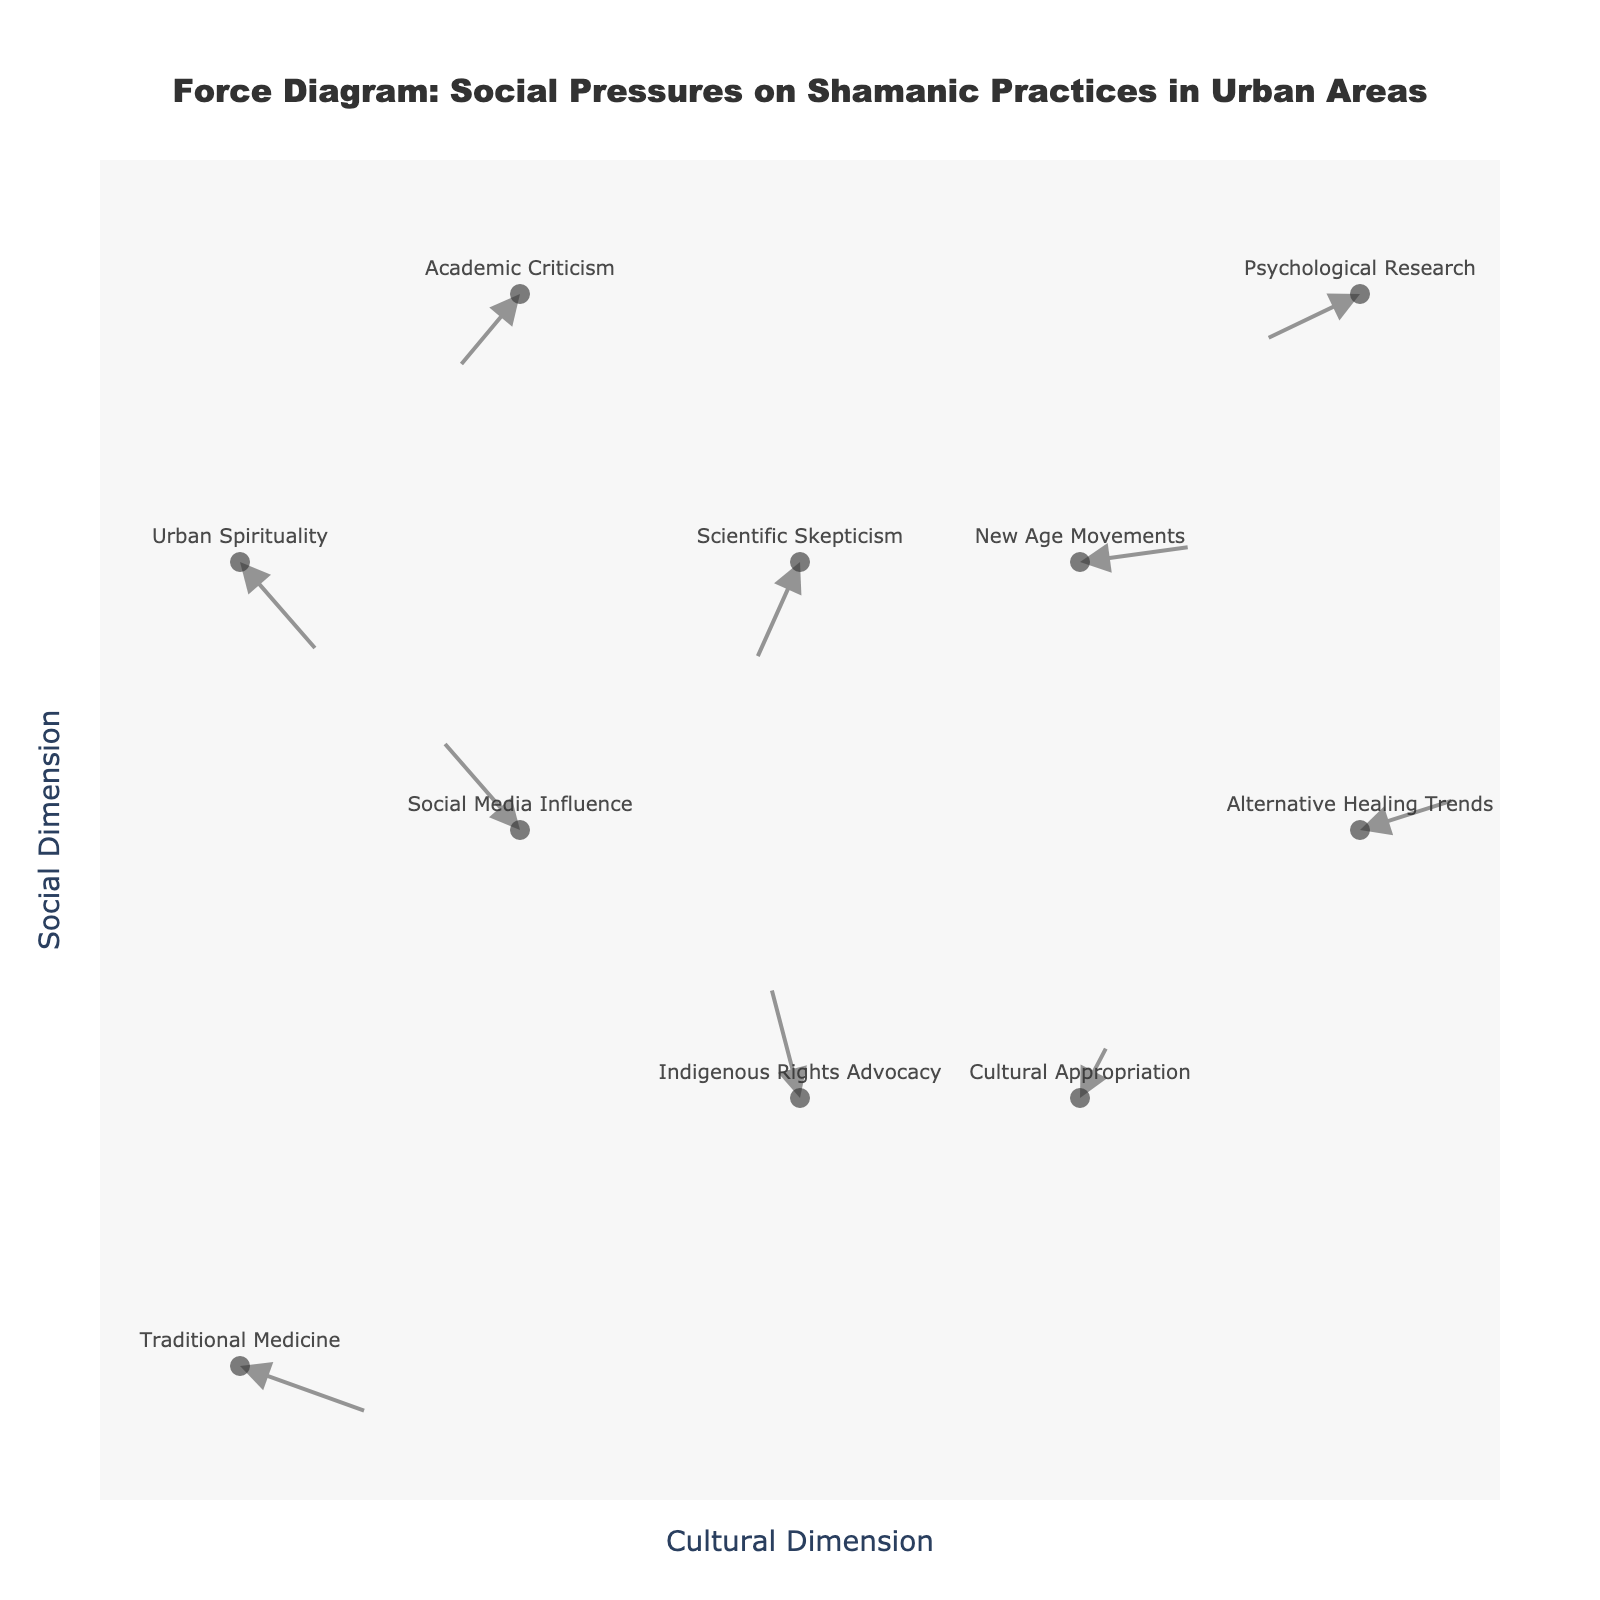How many labeled points are there in the diagram? Count the number of labels provided in the figure; there are 10 labeled points.
Answer: 10 What is the main title of the diagram? The main title is often found at the top of the figure. The title provided here is "Force Diagram: Social Pressures on Shamanic Practices in Urban Areas."
Answer: Force Diagram: Social Pressures on Shamanic Practices in Urban Areas Which factor shows the largest force (arrow length) influencing the adoption or rejection of shamanic practices? Calculate the length of each arrow using the formula sqrt(u^2 + v^2). The lengths correspond to the driving force. The largest value should be found and its corresponding label identified. "Indigenous Rights Advocacy" (with vector (-0.2, 0.8)) has the largest force.
Answer: Indigenous Rights Advocacy Which factor has the arrow pointing the most downward? Determine which factor has the largest negative value for the v-component of the vector, indicating the largest downward pointing arrow. "Scientific Skepticism" (-0.7) points most downward.
Answer: Scientific Skepticism Compare the forces associated with "Traditional Medicine" and "Urban Spirituality" and state which one has the longer arrow. First, calculate the force for each vector using the formula sqrt(u^2 + v^2). For "Traditional Medicine" (0.8, -0.3): sqrt(0.8^2 + -0.3^2) ≈ 0.854. For "Urban Spirituality" (0.5, -0.6): sqrt(0.5^2 + -0.6^2) ≈ 0.781. "Traditional Medicine" has a longer arrow.
Answer: Traditional Medicine What are the coordinates and direction (as a vector) of the factor "New Age Movements"? Identify the point labeled "New Age Movements" on the diagram and note its coordinates and vector direction. The coordinates are (3, 3) and the vector is (0.7, 0.1).
Answer: (3, 3) and (0.7, 0.1) If the factor "Scientific Skepticism" is pointing down-left and "Social Media Influence" is pointing up-right, what does this imply about their influences on shamanic practices in urban areas? "Scientific Skepticism" has a negative x and y component, indicating a discouraging force pushing away from shamanic practices. "Social Media Influence" has positive x and y components, indicating an encouraging force toward the adoption of shamanic practices. Therefore, "Scientific Skepticism" likely discourages while "Social Media Influence" encourages shamanic practices.
Answer: Discourages and encourages, respectively Which two factors are closest to each other in space on the diagram? Compare the Euclidean distances between each pair of points. The pair with the smallest distance is the closest. Distance between "Social Media Influence" (1, 2) and "Indigenous Rights Advocacy" (2, 1): sqrt((2-1)^2 + (1-2)^2) = sqrt(2) ≈ 1.414. This is the smallest distance.
Answer: Social Media Influence and Indigenous Rights Advocacy What does the note at the bottom of the figure say? The note is located at the bottom of the figure and provides a critical disclaimer. It says: "Note: This diagram represents hypothetical forces and should be interpreted critically."
Answer: Note: This diagram represents hypothetical forces and should be interpreted critically 